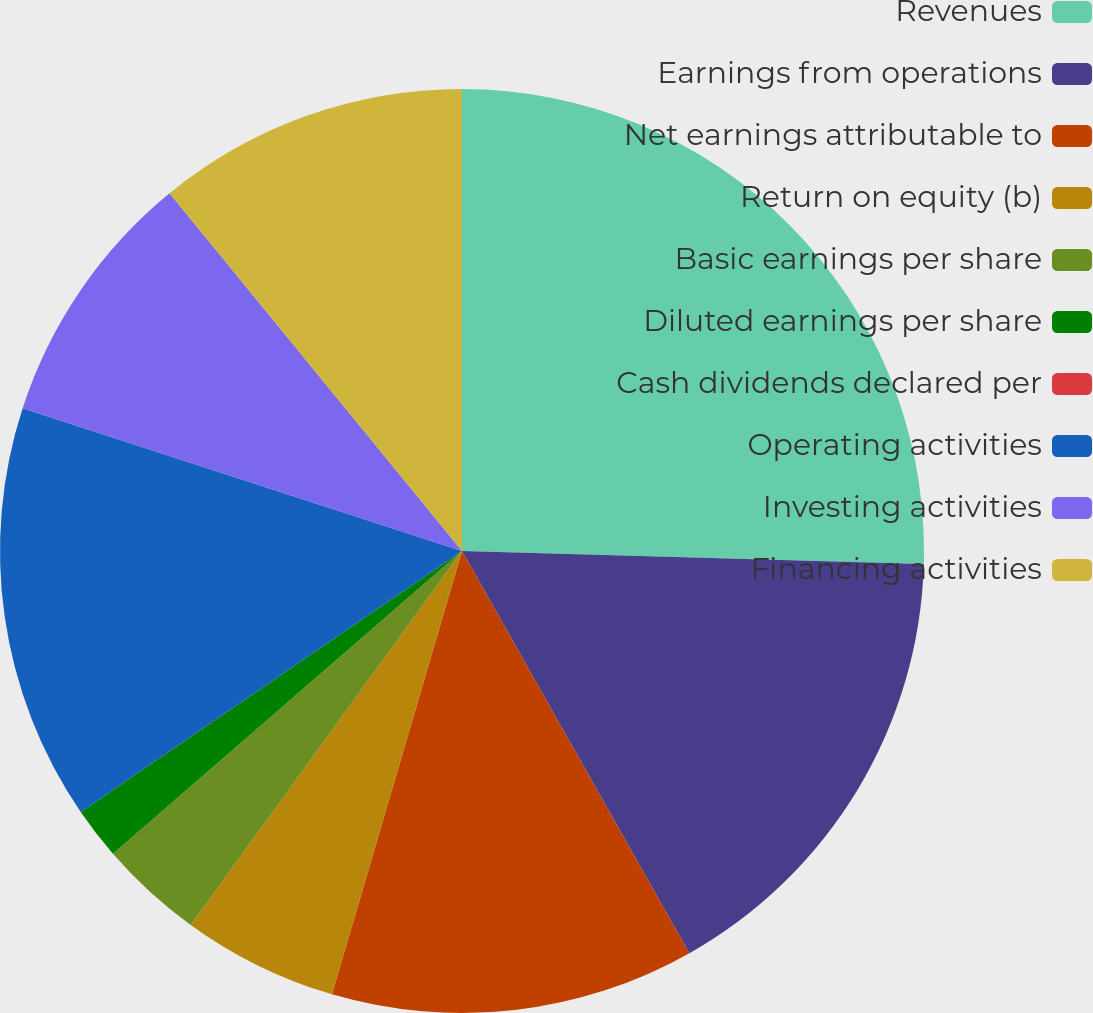Convert chart to OTSL. <chart><loc_0><loc_0><loc_500><loc_500><pie_chart><fcel>Revenues<fcel>Earnings from operations<fcel>Net earnings attributable to<fcel>Return on equity (b)<fcel>Basic earnings per share<fcel>Diluted earnings per share<fcel>Cash dividends declared per<fcel>Operating activities<fcel>Investing activities<fcel>Financing activities<nl><fcel>25.45%<fcel>16.36%<fcel>12.73%<fcel>5.45%<fcel>3.64%<fcel>1.82%<fcel>0.0%<fcel>14.55%<fcel>9.09%<fcel>10.91%<nl></chart> 